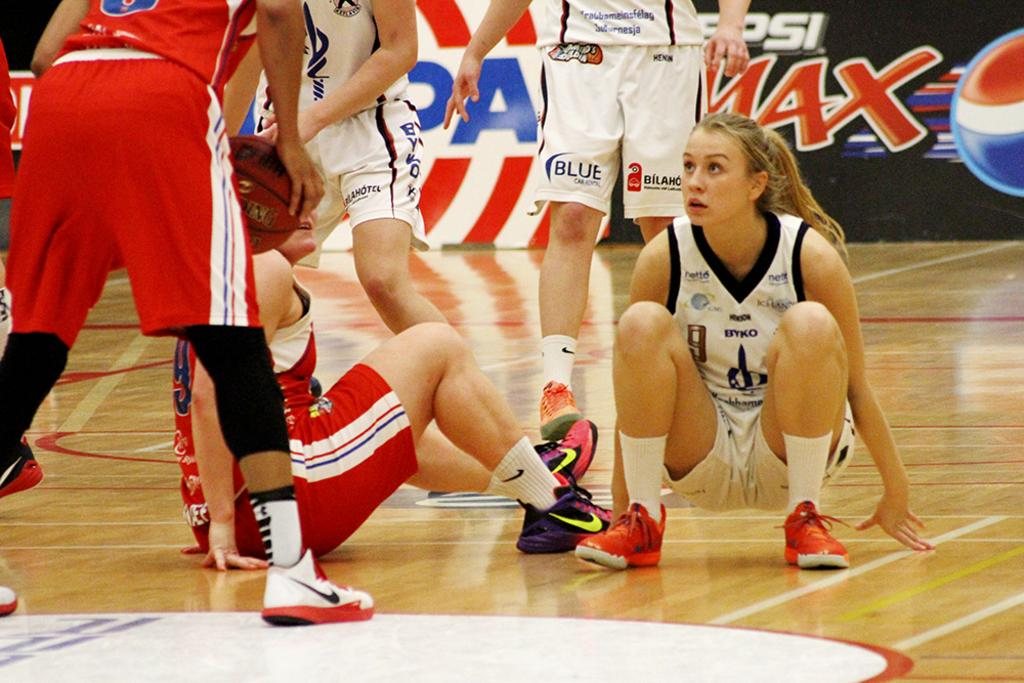<image>
Offer a succinct explanation of the picture presented. A group of female basketball players are playing in front of a Pepsi Max sign. 